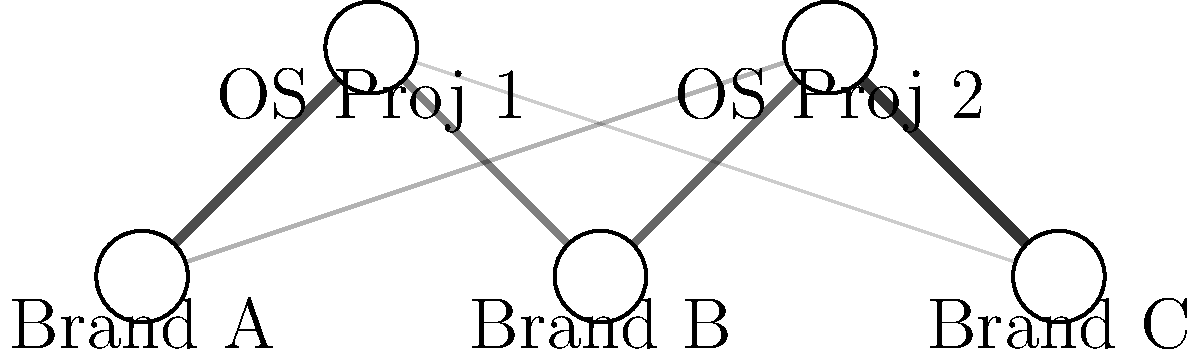Based on the network diagram showing the relationships between brands and open source projects, which brand is likely to have the most positive perception due to its open source contributions? To determine which brand has the most positive perception due to its open source contributions, we need to analyze the connections and their strengths in the network diagram:

1. Identify the brands and open source projects:
   - Brands: A, B, and C
   - Open Source Projects: OS Proj 1 and OS Proj 2

2. Analyze the connections for each brand:
   - Brand A:
     * Connected to OS Proj 1 with strength 0.7
     * Connected to OS Proj 2 with strength 0.3
     * Total strength: 0.7 + 0.3 = 1.0

   - Brand B:
     * Connected to OS Proj 1 with strength 0.5
     * Connected to OS Proj 2 with strength 0.6
     * Total strength: 0.5 + 0.6 = 1.1

   - Brand C:
     * Connected to OS Proj 1 with strength 0.2
     * Connected to OS Proj 2 with strength 0.8
     * Total strength: 0.2 + 0.8 = 1.0

3. Compare the total connection strengths:
   - Brand A: 1.0
   - Brand B: 1.1
   - Brand C: 1.0

4. Conclusion:
   Brand B has the highest total connection strength (1.1) to open source projects, indicating the strongest overall involvement in open source contributions.

Therefore, Brand B is likely to have the most positive perception due to its open source contributions.
Answer: Brand B 